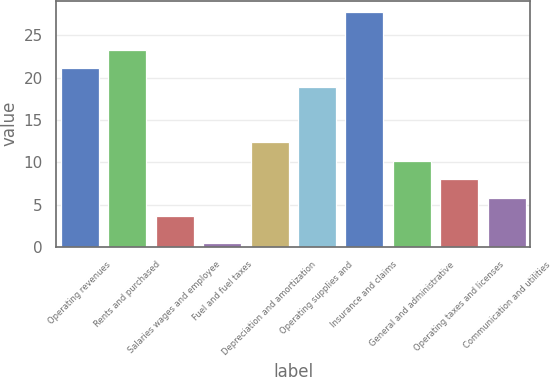Convert chart to OTSL. <chart><loc_0><loc_0><loc_500><loc_500><bar_chart><fcel>Operating revenues<fcel>Rents and purchased<fcel>Salaries wages and employee<fcel>Fuel and fuel taxes<fcel>Depreciation and amortization<fcel>Operating supplies and<fcel>Insurance and claims<fcel>General and administrative<fcel>Operating taxes and licenses<fcel>Communication and utilities<nl><fcel>21.12<fcel>23.31<fcel>3.6<fcel>0.5<fcel>12.36<fcel>18.93<fcel>27.69<fcel>10.17<fcel>7.98<fcel>5.79<nl></chart> 